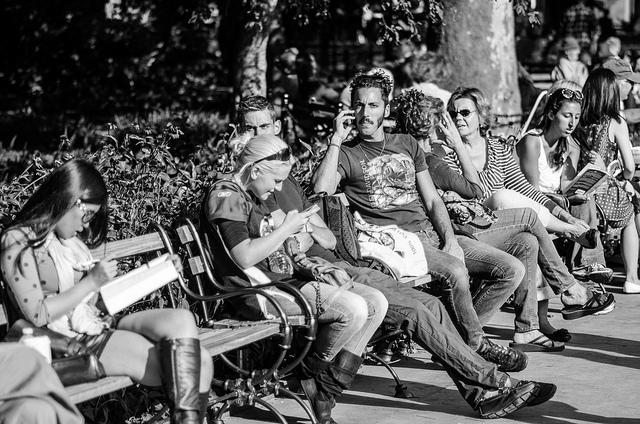What are they all doing? sitting 